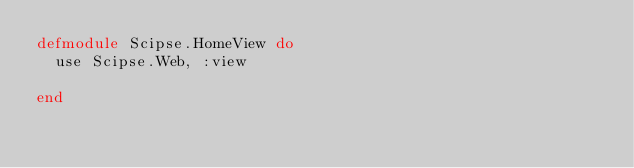Convert code to text. <code><loc_0><loc_0><loc_500><loc_500><_Elixir_>defmodule Scipse.HomeView do
  use Scipse.Web, :view

end
</code> 